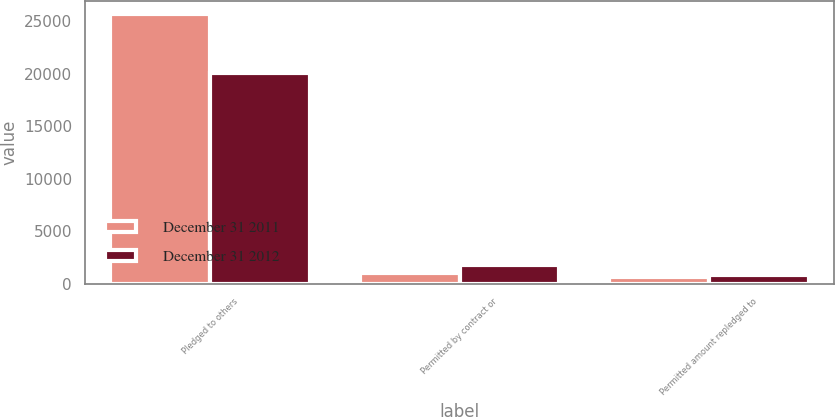Convert chart. <chart><loc_0><loc_0><loc_500><loc_500><stacked_bar_chart><ecel><fcel>Pledged to others<fcel>Permitted by contract or<fcel>Permitted amount repledged to<nl><fcel>December 31 2011<fcel>25648<fcel>1015<fcel>685<nl><fcel>December 31 2012<fcel>20109<fcel>1796<fcel>892<nl></chart> 